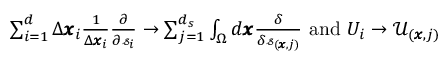Convert formula to latex. <formula><loc_0><loc_0><loc_500><loc_500>\begin{array} { r } { \sum _ { i = 1 } ^ { d } \Delta \pm b { x } _ { i } \frac { 1 } { \Delta \pm b { x } _ { i } } \frac { \partial } { \partial \ m a t h s c r { s } _ { i } } \rightarrow \sum _ { j = 1 } ^ { d _ { s } } \int _ { \Omega } d \pm b { x } \frac { \delta } { \delta \ m a t h s c r { s } _ { ( \pm b { x } , j ) } } a n d U _ { i } \rightarrow \mathcal { U } _ { ( \pm b { x } , j ) } } \end{array}</formula> 